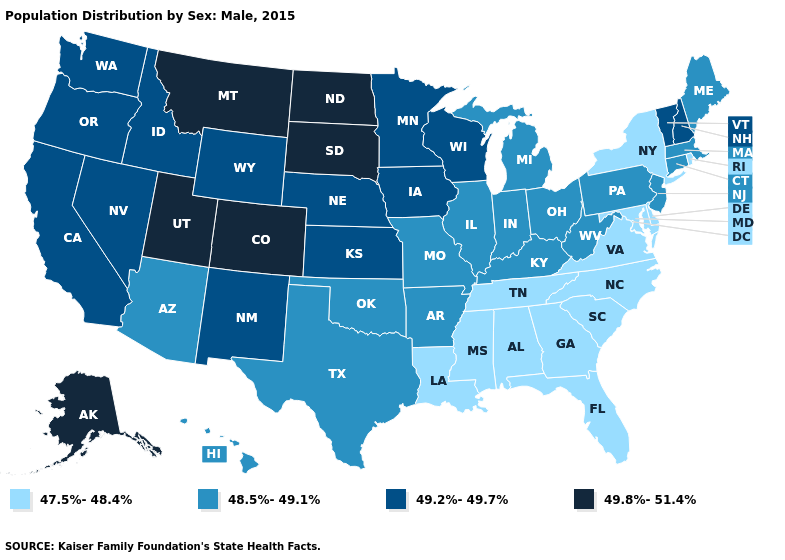Name the states that have a value in the range 49.8%-51.4%?
Write a very short answer. Alaska, Colorado, Montana, North Dakota, South Dakota, Utah. What is the value of Utah?
Write a very short answer. 49.8%-51.4%. Among the states that border Texas , which have the lowest value?
Quick response, please. Louisiana. What is the highest value in states that border Oklahoma?
Concise answer only. 49.8%-51.4%. Among the states that border Iowa , which have the lowest value?
Concise answer only. Illinois, Missouri. Name the states that have a value in the range 49.2%-49.7%?
Write a very short answer. California, Idaho, Iowa, Kansas, Minnesota, Nebraska, Nevada, New Hampshire, New Mexico, Oregon, Vermont, Washington, Wisconsin, Wyoming. What is the value of Rhode Island?
Give a very brief answer. 47.5%-48.4%. Does the map have missing data?
Quick response, please. No. What is the value of Missouri?
Quick response, please. 48.5%-49.1%. Name the states that have a value in the range 49.2%-49.7%?
Be succinct. California, Idaho, Iowa, Kansas, Minnesota, Nebraska, Nevada, New Hampshire, New Mexico, Oregon, Vermont, Washington, Wisconsin, Wyoming. Which states hav the highest value in the South?
Concise answer only. Arkansas, Kentucky, Oklahoma, Texas, West Virginia. What is the value of Illinois?
Be succinct. 48.5%-49.1%. Among the states that border Colorado , which have the lowest value?
Quick response, please. Arizona, Oklahoma. Name the states that have a value in the range 49.2%-49.7%?
Short answer required. California, Idaho, Iowa, Kansas, Minnesota, Nebraska, Nevada, New Hampshire, New Mexico, Oregon, Vermont, Washington, Wisconsin, Wyoming. Name the states that have a value in the range 49.8%-51.4%?
Quick response, please. Alaska, Colorado, Montana, North Dakota, South Dakota, Utah. 